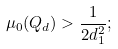Convert formula to latex. <formula><loc_0><loc_0><loc_500><loc_500>\mu _ { 0 } ( Q _ { d } ) > \frac { 1 } { 2 d _ { 1 } ^ { 2 } } ;</formula> 